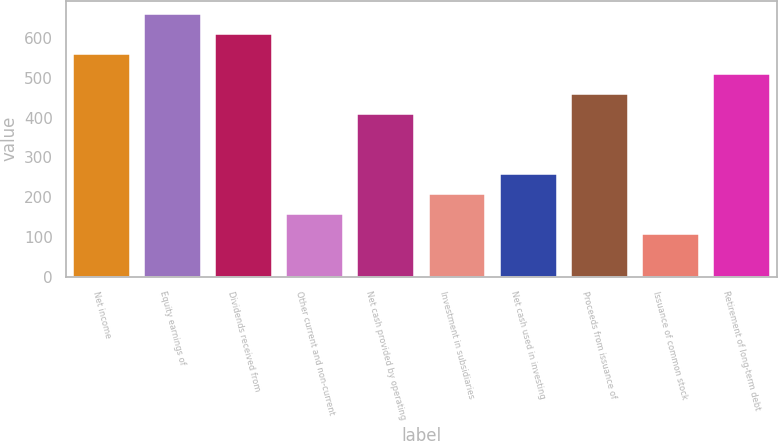Convert chart. <chart><loc_0><loc_0><loc_500><loc_500><bar_chart><fcel>Net income<fcel>Equity earnings of<fcel>Dividends received from<fcel>Other current and non-current<fcel>Net cash provided by operating<fcel>Investment in subsidiaries<fcel>Net cash used in investing<fcel>Proceeds from issuance of<fcel>Issuance of common stock<fcel>Retirement of long-term debt<nl><fcel>560.4<fcel>661.2<fcel>610.8<fcel>157.2<fcel>409.2<fcel>207.6<fcel>258<fcel>459.6<fcel>106.8<fcel>510<nl></chart> 